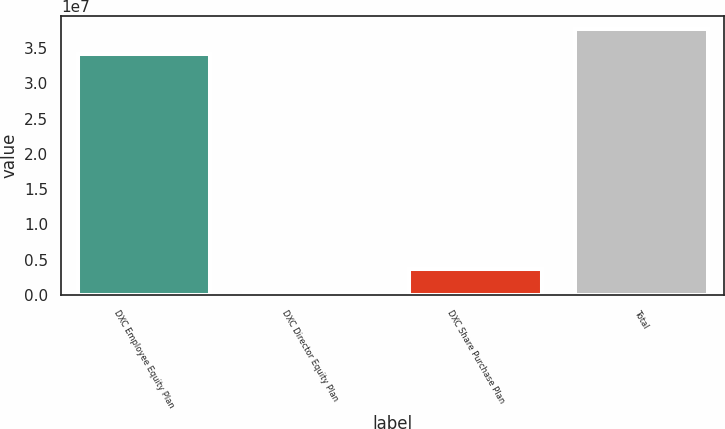Convert chart to OTSL. <chart><loc_0><loc_0><loc_500><loc_500><bar_chart><fcel>DXC Employee Equity Plan<fcel>DXC Director Equity Plan<fcel>DXC Share Purchase Plan<fcel>Total<nl><fcel>3.42e+07<fcel>230000<fcel>3.675e+06<fcel>3.7645e+07<nl></chart> 